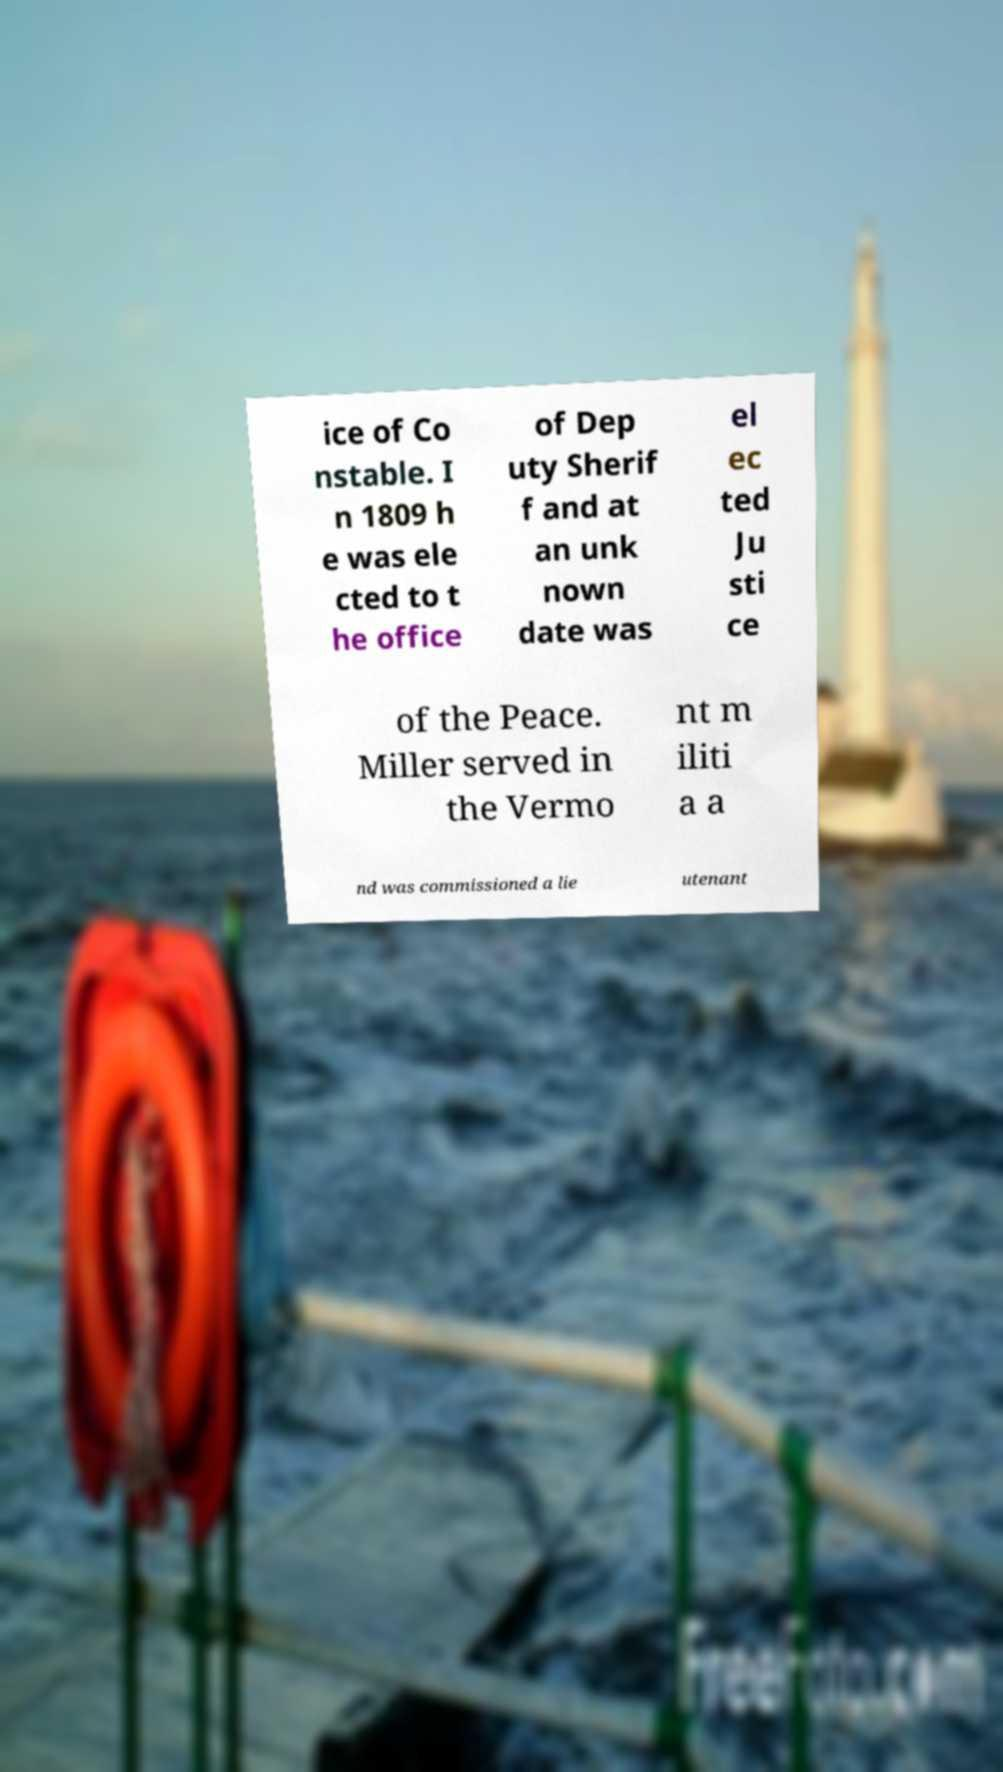There's text embedded in this image that I need extracted. Can you transcribe it verbatim? ice of Co nstable. I n 1809 h e was ele cted to t he office of Dep uty Sherif f and at an unk nown date was el ec ted Ju sti ce of the Peace. Miller served in the Vermo nt m iliti a a nd was commissioned a lie utenant 